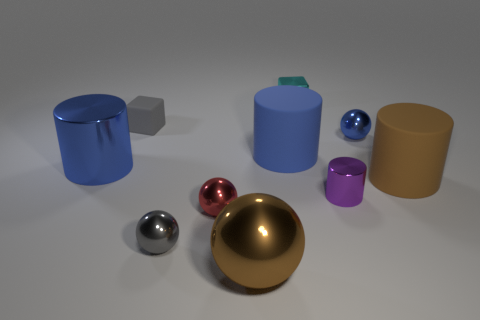How many tiny objects are the same color as the tiny rubber block? Upon examination of the image, there appears to be one tiny object that matches the color of the tiny rubber block – it's the small sphere to the right of the golden sphere. 